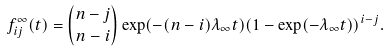Convert formula to latex. <formula><loc_0><loc_0><loc_500><loc_500>f ^ { \infty } _ { i j } ( t ) = { n - j \choose n - i } \exp ( - ( n - i ) \lambda _ { \infty } t ) ( 1 - \exp ( - \lambda _ { \infty } t ) ) ^ { i - j } .</formula> 